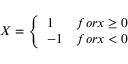<formula> <loc_0><loc_0><loc_500><loc_500>X = \left \{ \begin{array} { l l } { 1 } & { f o r x \geq 0 } \\ { - 1 } & { f o r x < 0 } \end{array}</formula> 